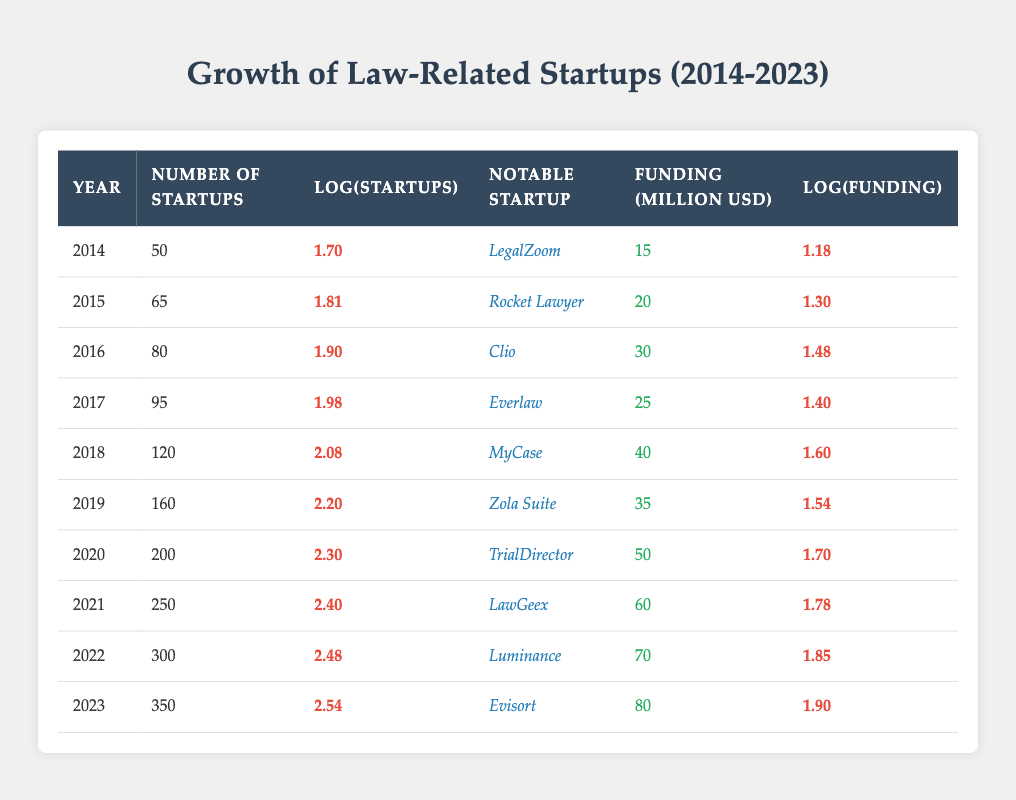What was the number of startups in 2020? According to the table, the number of startups in 2020 is found directly in the respective row for that year. It shows that there were 200 startups in that year.
Answer: 200 Which year had the highest funding? By examining the funding column for each year, the maximum value is 80 million USD, which corresponds to the year 2023.
Answer: 2023 What is the average number of startups from 2014 to 2023? To find the average, first sum the number of startups over the years: 50 + 65 + 80 + 95 + 120 + 160 + 200 + 250 + 300 + 350 = 1,670. Then divide by the total number of years (10) to get the average: 1,670 / 10 = 167.
Answer: 167 Is there a notable startup listed for the year 2021? Yes, the notable startup for the year 2021 is LawGeex, which can be found in the respective row for that year in the table.
Answer: Yes What is the difference in funding between 2019 and 2021? The funding for 2019 is 35 million USD and for 2021 is 60 million USD. To find the difference, subtract the earlier year from the later year: 60 - 35 = 25.
Answer: 25 